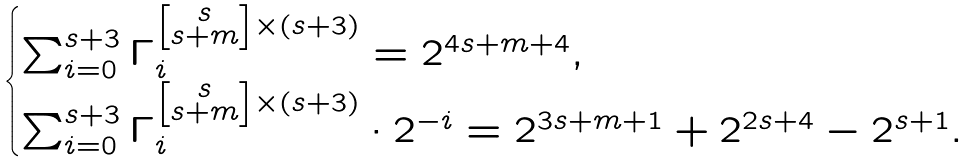<formula> <loc_0><loc_0><loc_500><loc_500>\begin{cases} \sum _ { i = 0 } ^ { s + 3 } \Gamma _ { i } ^ { \left [ \substack { s \\ s + m } \right ] \times ( s + 3 ) } = 2 ^ { 4 s + m + 4 } , \\ \sum _ { i = 0 } ^ { s + 3 } \Gamma _ { i } ^ { \left [ \substack { s \\ s + m } \right ] \times ( s + 3 ) } \cdot 2 ^ { - i } = 2 ^ { 3 s + m + 1 } + 2 ^ { 2 s + 4 } - 2 ^ { s + 1 } . \end{cases}</formula> 